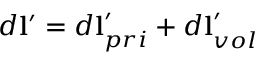Convert formula to latex. <formula><loc_0><loc_0><loc_500><loc_500>d l ^ { \prime } = d l _ { p r i } ^ { \prime } + d l _ { v o l } ^ { \prime }</formula> 